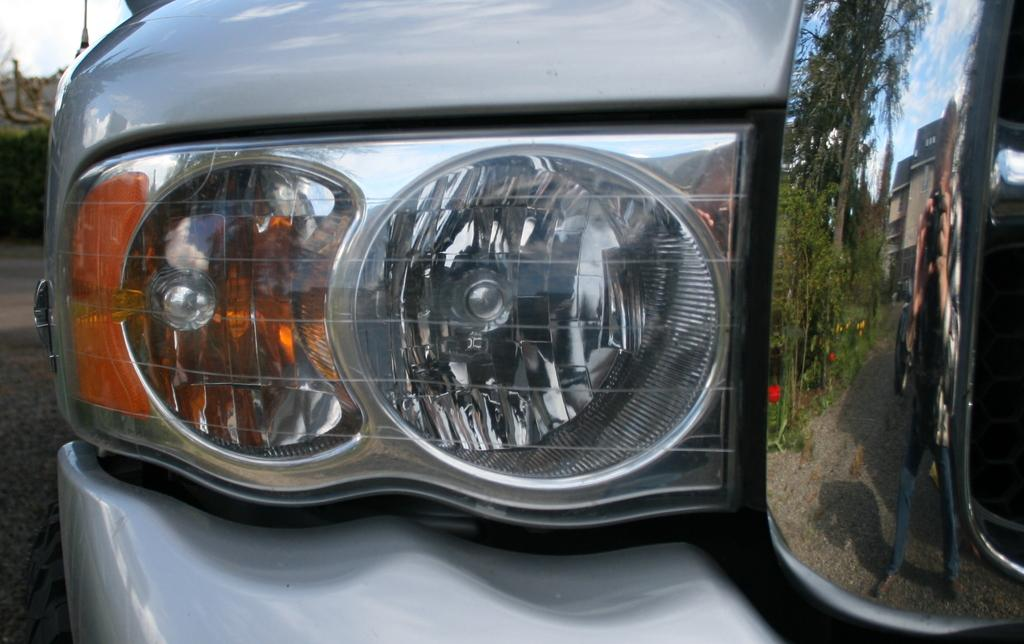What is the main subject of the image? The main subject of the image is the headlight of a vehicle. What can be seen in the reflection on the right side of the image? In the reflection, there are trees, a person, a building, clouds, and the sky visible. Can you describe the reflection in more detail? The reflection shows trees, a person, a building, clouds, and the sky on the right side of the image. What is the weight of the pickle in the image? There is no pickle present in the image, so its weight cannot be determined. What type of thing is being reflected in the image? The reflection in the image shows trees, a person, a building, clouds, and the sky, not a "thing." 